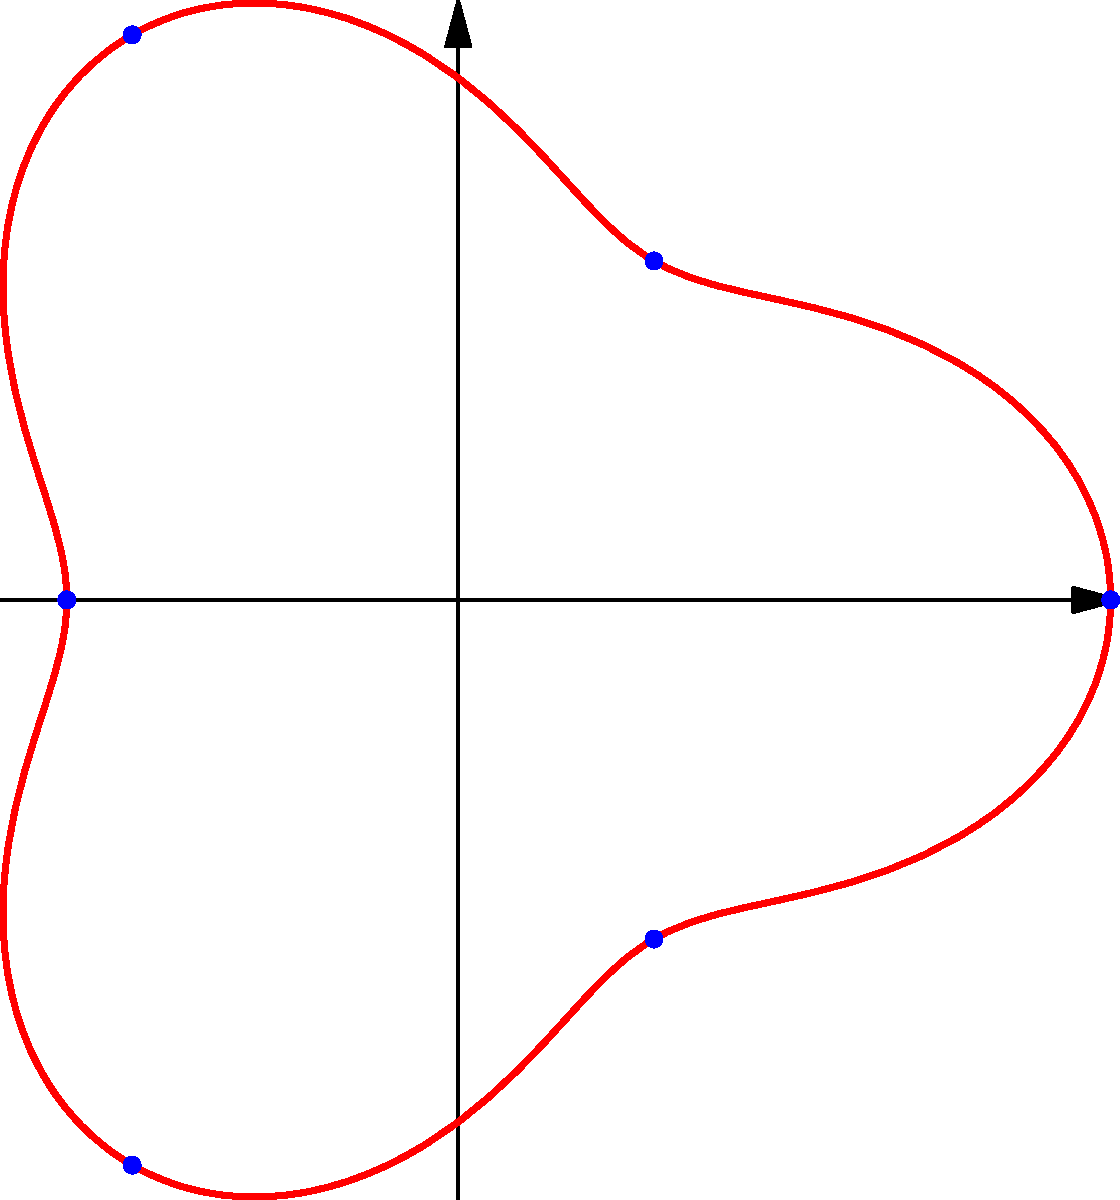The polar equation $r = 2 + 0.5\cos(3\theta)$ models the boundary of a circular habitat where an invasive species is spreading. If the species spreads uniformly from the center, at which angles $\theta$ (in radians) will it reach the boundary first? To determine where the invasive species will reach the boundary first, we need to find the minimum radial distance from the center. This occurs where $r$ is at its minimum value.

1) The equation is $r = 2 + 0.5\cos(3\theta)$

2) The minimum value of $r$ occurs when $\cos(3\theta)$ is at its minimum, which is -1.

3) $\cos(3\theta) = -1$ when $3\theta = \pi, 3\pi, 5\pi, ...$

4) Solving for $\theta$:
   $\theta = \frac{\pi}{3}, \pi, \frac{5\pi}{3}, ...$

5) These angles repeat every $2\pi$, so in the interval $[0, 2\pi]$, the minimum occurs at:
   $\theta = \frac{\pi}{3}, \pi, \frac{5\pi}{3}$

6) These angles correspond to the "inward" points of the curve, where the boundary is closest to the center.

Therefore, the invasive species will reach the boundary first at these three angles.
Answer: $\frac{\pi}{3}, \pi, \frac{5\pi}{3}$ 